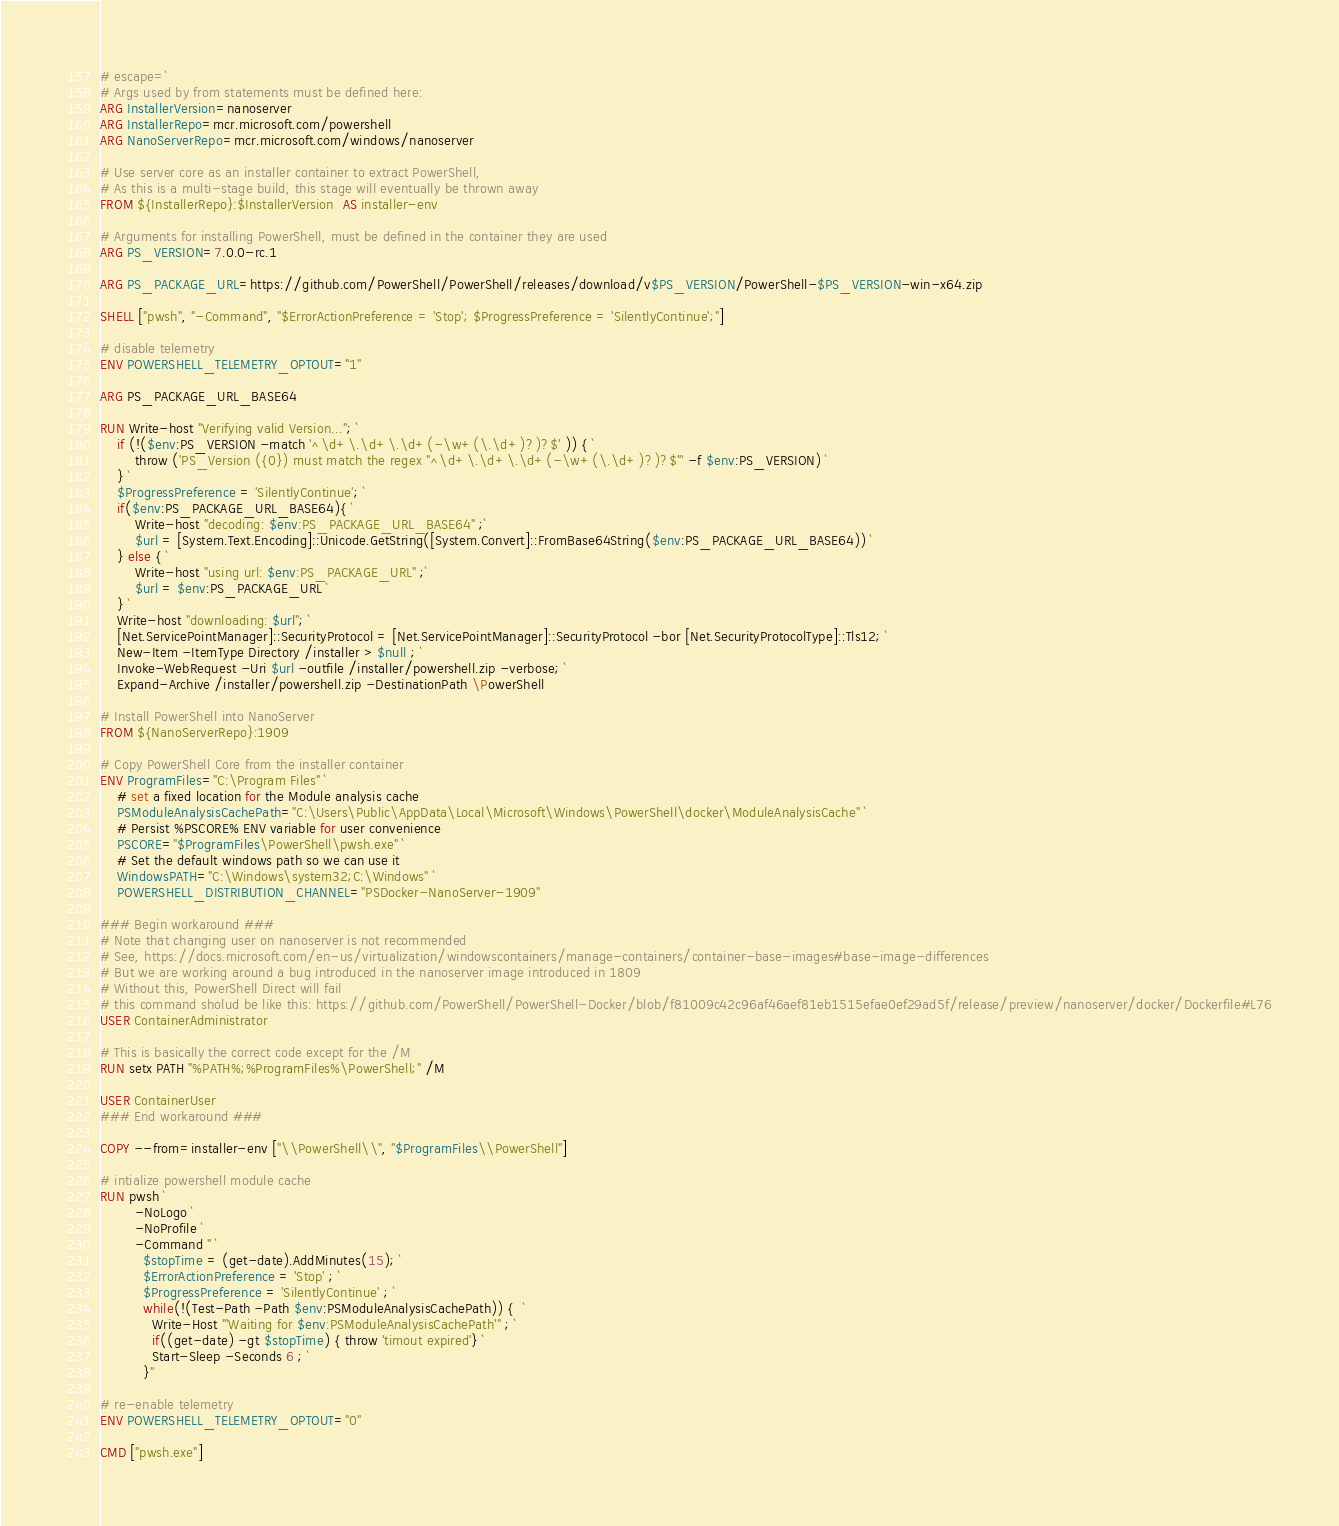<code> <loc_0><loc_0><loc_500><loc_500><_Dockerfile_># escape=`
# Args used by from statements must be defined here:
ARG InstallerVersion=nanoserver
ARG InstallerRepo=mcr.microsoft.com/powershell
ARG NanoServerRepo=mcr.microsoft.com/windows/nanoserver

# Use server core as an installer container to extract PowerShell,
# As this is a multi-stage build, this stage will eventually be thrown away
FROM ${InstallerRepo}:$InstallerVersion  AS installer-env

# Arguments for installing PowerShell, must be defined in the container they are used
ARG PS_VERSION=7.0.0-rc.1

ARG PS_PACKAGE_URL=https://github.com/PowerShell/PowerShell/releases/download/v$PS_VERSION/PowerShell-$PS_VERSION-win-x64.zip

SHELL ["pwsh", "-Command", "$ErrorActionPreference = 'Stop'; $ProgressPreference = 'SilentlyContinue';"]

# disable telemetry
ENV POWERSHELL_TELEMETRY_OPTOUT="1"

ARG PS_PACKAGE_URL_BASE64

RUN Write-host "Verifying valid Version..."; `
    if (!($env:PS_VERSION -match '^\d+\.\d+\.\d+(-\w+(\.\d+)?)?$' )) { `
        throw ('PS_Version ({0}) must match the regex "^\d+\.\d+\.\d+(-\w+(\.\d+)?)?$"' -f $env:PS_VERSION) `
    } `
    $ProgressPreference = 'SilentlyContinue'; `
    if($env:PS_PACKAGE_URL_BASE64){ `
        Write-host "decoding: $env:PS_PACKAGE_URL_BASE64" ;`
        $url = [System.Text.Encoding]::Unicode.GetString([System.Convert]::FromBase64String($env:PS_PACKAGE_URL_BASE64)) `
    } else { `
        Write-host "using url: $env:PS_PACKAGE_URL" ;`
        $url = $env:PS_PACKAGE_URL `
    } `
    Write-host "downloading: $url"; `
    [Net.ServicePointManager]::SecurityProtocol = [Net.ServicePointManager]::SecurityProtocol -bor [Net.SecurityProtocolType]::Tls12; `
    New-Item -ItemType Directory /installer > $null ; `
    Invoke-WebRequest -Uri $url -outfile /installer/powershell.zip -verbose; `
    Expand-Archive /installer/powershell.zip -DestinationPath \PowerShell

# Install PowerShell into NanoServer
FROM ${NanoServerRepo}:1909

# Copy PowerShell Core from the installer container
ENV ProgramFiles="C:\Program Files" `
    # set a fixed location for the Module analysis cache
    PSModuleAnalysisCachePath="C:\Users\Public\AppData\Local\Microsoft\Windows\PowerShell\docker\ModuleAnalysisCache" `
    # Persist %PSCORE% ENV variable for user convenience
    PSCORE="$ProgramFiles\PowerShell\pwsh.exe" `
    # Set the default windows path so we can use it
    WindowsPATH="C:\Windows\system32;C:\Windows" `
    POWERSHELL_DISTRIBUTION_CHANNEL="PSDocker-NanoServer-1909"

### Begin workaround ###
# Note that changing user on nanoserver is not recommended
# See, https://docs.microsoft.com/en-us/virtualization/windowscontainers/manage-containers/container-base-images#base-image-differences
# But we are working around a bug introduced in the nanoserver image introduced in 1809
# Without this, PowerShell Direct will fail
# this command sholud be like this: https://github.com/PowerShell/PowerShell-Docker/blob/f81009c42c96af46aef81eb1515efae0ef29ad5f/release/preview/nanoserver/docker/Dockerfile#L76
USER ContainerAdministrator

# This is basically the correct code except for the /M
RUN setx PATH "%PATH%;%ProgramFiles%\PowerShell;" /M

USER ContainerUser
### End workaround ###

COPY --from=installer-env ["\\PowerShell\\", "$ProgramFiles\\PowerShell"]

# intialize powershell module cache
RUN pwsh `
        -NoLogo `
        -NoProfile `
        -Command " `
          $stopTime = (get-date).AddMinutes(15); `
          $ErrorActionPreference = 'Stop' ; `
          $ProgressPreference = 'SilentlyContinue' ; `
          while(!(Test-Path -Path $env:PSModuleAnalysisCachePath)) {  `
            Write-Host "'Waiting for $env:PSModuleAnalysisCachePath'" ; `
            if((get-date) -gt $stopTime) { throw 'timout expired'} `
            Start-Sleep -Seconds 6 ; `
          }"

# re-enable telemetry
ENV POWERSHELL_TELEMETRY_OPTOUT="0"

CMD ["pwsh.exe"]
</code> 